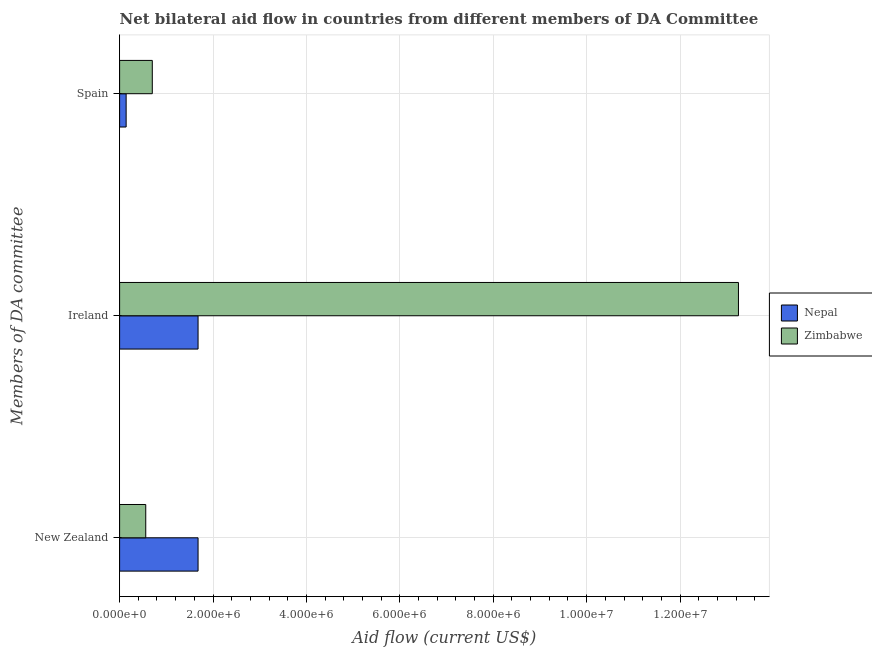How many different coloured bars are there?
Provide a succinct answer. 2. How many bars are there on the 1st tick from the top?
Provide a succinct answer. 2. How many bars are there on the 2nd tick from the bottom?
Offer a terse response. 2. What is the label of the 2nd group of bars from the top?
Ensure brevity in your answer.  Ireland. What is the amount of aid provided by spain in Zimbabwe?
Make the answer very short. 7.00e+05. Across all countries, what is the maximum amount of aid provided by spain?
Keep it short and to the point. 7.00e+05. Across all countries, what is the minimum amount of aid provided by spain?
Give a very brief answer. 1.40e+05. In which country was the amount of aid provided by new zealand maximum?
Provide a short and direct response. Nepal. In which country was the amount of aid provided by new zealand minimum?
Offer a terse response. Zimbabwe. What is the total amount of aid provided by ireland in the graph?
Offer a terse response. 1.49e+07. What is the difference between the amount of aid provided by new zealand in Zimbabwe and that in Nepal?
Your answer should be compact. -1.12e+06. What is the difference between the amount of aid provided by new zealand in Zimbabwe and the amount of aid provided by ireland in Nepal?
Your answer should be compact. -1.12e+06. What is the average amount of aid provided by new zealand per country?
Your answer should be compact. 1.12e+06. What is the difference between the amount of aid provided by new zealand and amount of aid provided by spain in Zimbabwe?
Make the answer very short. -1.40e+05. In how many countries, is the amount of aid provided by spain greater than 11200000 US$?
Provide a short and direct response. 0. What is the ratio of the amount of aid provided by ireland in Zimbabwe to that in Nepal?
Offer a terse response. 7.89. Is the amount of aid provided by new zealand in Zimbabwe less than that in Nepal?
Provide a short and direct response. Yes. Is the difference between the amount of aid provided by new zealand in Nepal and Zimbabwe greater than the difference between the amount of aid provided by ireland in Nepal and Zimbabwe?
Give a very brief answer. Yes. What is the difference between the highest and the second highest amount of aid provided by ireland?
Provide a short and direct response. 1.16e+07. What is the difference between the highest and the lowest amount of aid provided by ireland?
Ensure brevity in your answer.  1.16e+07. Is the sum of the amount of aid provided by new zealand in Zimbabwe and Nepal greater than the maximum amount of aid provided by ireland across all countries?
Provide a succinct answer. No. What does the 1st bar from the top in Spain represents?
Offer a terse response. Zimbabwe. What does the 1st bar from the bottom in New Zealand represents?
Give a very brief answer. Nepal. How many bars are there?
Make the answer very short. 6. Does the graph contain any zero values?
Offer a terse response. No. How many legend labels are there?
Provide a succinct answer. 2. How are the legend labels stacked?
Provide a short and direct response. Vertical. What is the title of the graph?
Give a very brief answer. Net bilateral aid flow in countries from different members of DA Committee. Does "Latvia" appear as one of the legend labels in the graph?
Provide a succinct answer. No. What is the label or title of the Y-axis?
Make the answer very short. Members of DA committee. What is the Aid flow (current US$) of Nepal in New Zealand?
Your answer should be very brief. 1.68e+06. What is the Aid flow (current US$) of Zimbabwe in New Zealand?
Offer a terse response. 5.60e+05. What is the Aid flow (current US$) in Nepal in Ireland?
Offer a very short reply. 1.68e+06. What is the Aid flow (current US$) of Zimbabwe in Ireland?
Provide a short and direct response. 1.32e+07. What is the Aid flow (current US$) of Zimbabwe in Spain?
Make the answer very short. 7.00e+05. Across all Members of DA committee, what is the maximum Aid flow (current US$) of Nepal?
Make the answer very short. 1.68e+06. Across all Members of DA committee, what is the maximum Aid flow (current US$) of Zimbabwe?
Keep it short and to the point. 1.32e+07. Across all Members of DA committee, what is the minimum Aid flow (current US$) of Nepal?
Keep it short and to the point. 1.40e+05. Across all Members of DA committee, what is the minimum Aid flow (current US$) of Zimbabwe?
Offer a terse response. 5.60e+05. What is the total Aid flow (current US$) in Nepal in the graph?
Your answer should be very brief. 3.50e+06. What is the total Aid flow (current US$) in Zimbabwe in the graph?
Offer a very short reply. 1.45e+07. What is the difference between the Aid flow (current US$) of Nepal in New Zealand and that in Ireland?
Offer a very short reply. 0. What is the difference between the Aid flow (current US$) of Zimbabwe in New Zealand and that in Ireland?
Ensure brevity in your answer.  -1.27e+07. What is the difference between the Aid flow (current US$) in Nepal in New Zealand and that in Spain?
Offer a terse response. 1.54e+06. What is the difference between the Aid flow (current US$) of Nepal in Ireland and that in Spain?
Offer a very short reply. 1.54e+06. What is the difference between the Aid flow (current US$) of Zimbabwe in Ireland and that in Spain?
Your answer should be very brief. 1.26e+07. What is the difference between the Aid flow (current US$) of Nepal in New Zealand and the Aid flow (current US$) of Zimbabwe in Ireland?
Offer a very short reply. -1.16e+07. What is the difference between the Aid flow (current US$) in Nepal in New Zealand and the Aid flow (current US$) in Zimbabwe in Spain?
Give a very brief answer. 9.80e+05. What is the difference between the Aid flow (current US$) of Nepal in Ireland and the Aid flow (current US$) of Zimbabwe in Spain?
Offer a terse response. 9.80e+05. What is the average Aid flow (current US$) in Nepal per Members of DA committee?
Provide a short and direct response. 1.17e+06. What is the average Aid flow (current US$) of Zimbabwe per Members of DA committee?
Ensure brevity in your answer.  4.84e+06. What is the difference between the Aid flow (current US$) of Nepal and Aid flow (current US$) of Zimbabwe in New Zealand?
Offer a terse response. 1.12e+06. What is the difference between the Aid flow (current US$) in Nepal and Aid flow (current US$) in Zimbabwe in Ireland?
Your answer should be very brief. -1.16e+07. What is the difference between the Aid flow (current US$) in Nepal and Aid flow (current US$) in Zimbabwe in Spain?
Your answer should be very brief. -5.60e+05. What is the ratio of the Aid flow (current US$) of Nepal in New Zealand to that in Ireland?
Keep it short and to the point. 1. What is the ratio of the Aid flow (current US$) in Zimbabwe in New Zealand to that in Ireland?
Give a very brief answer. 0.04. What is the ratio of the Aid flow (current US$) of Zimbabwe in New Zealand to that in Spain?
Your response must be concise. 0.8. What is the ratio of the Aid flow (current US$) of Nepal in Ireland to that in Spain?
Give a very brief answer. 12. What is the ratio of the Aid flow (current US$) in Zimbabwe in Ireland to that in Spain?
Make the answer very short. 18.93. What is the difference between the highest and the second highest Aid flow (current US$) in Nepal?
Provide a short and direct response. 0. What is the difference between the highest and the second highest Aid flow (current US$) of Zimbabwe?
Provide a succinct answer. 1.26e+07. What is the difference between the highest and the lowest Aid flow (current US$) in Nepal?
Provide a succinct answer. 1.54e+06. What is the difference between the highest and the lowest Aid flow (current US$) of Zimbabwe?
Provide a short and direct response. 1.27e+07. 